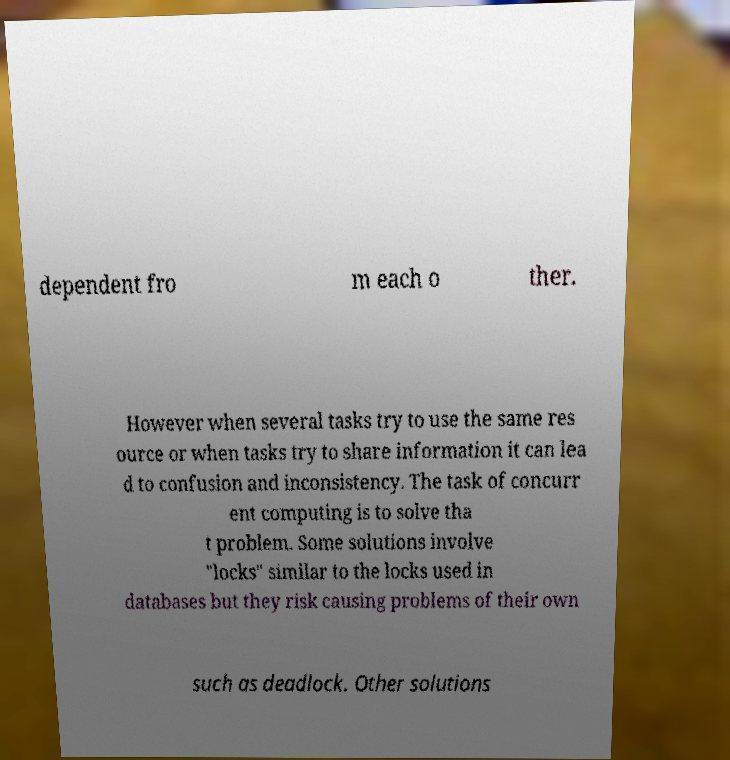Could you extract and type out the text from this image? dependent fro m each o ther. However when several tasks try to use the same res ource or when tasks try to share information it can lea d to confusion and inconsistency. The task of concurr ent computing is to solve tha t problem. Some solutions involve "locks" similar to the locks used in databases but they risk causing problems of their own such as deadlock. Other solutions 